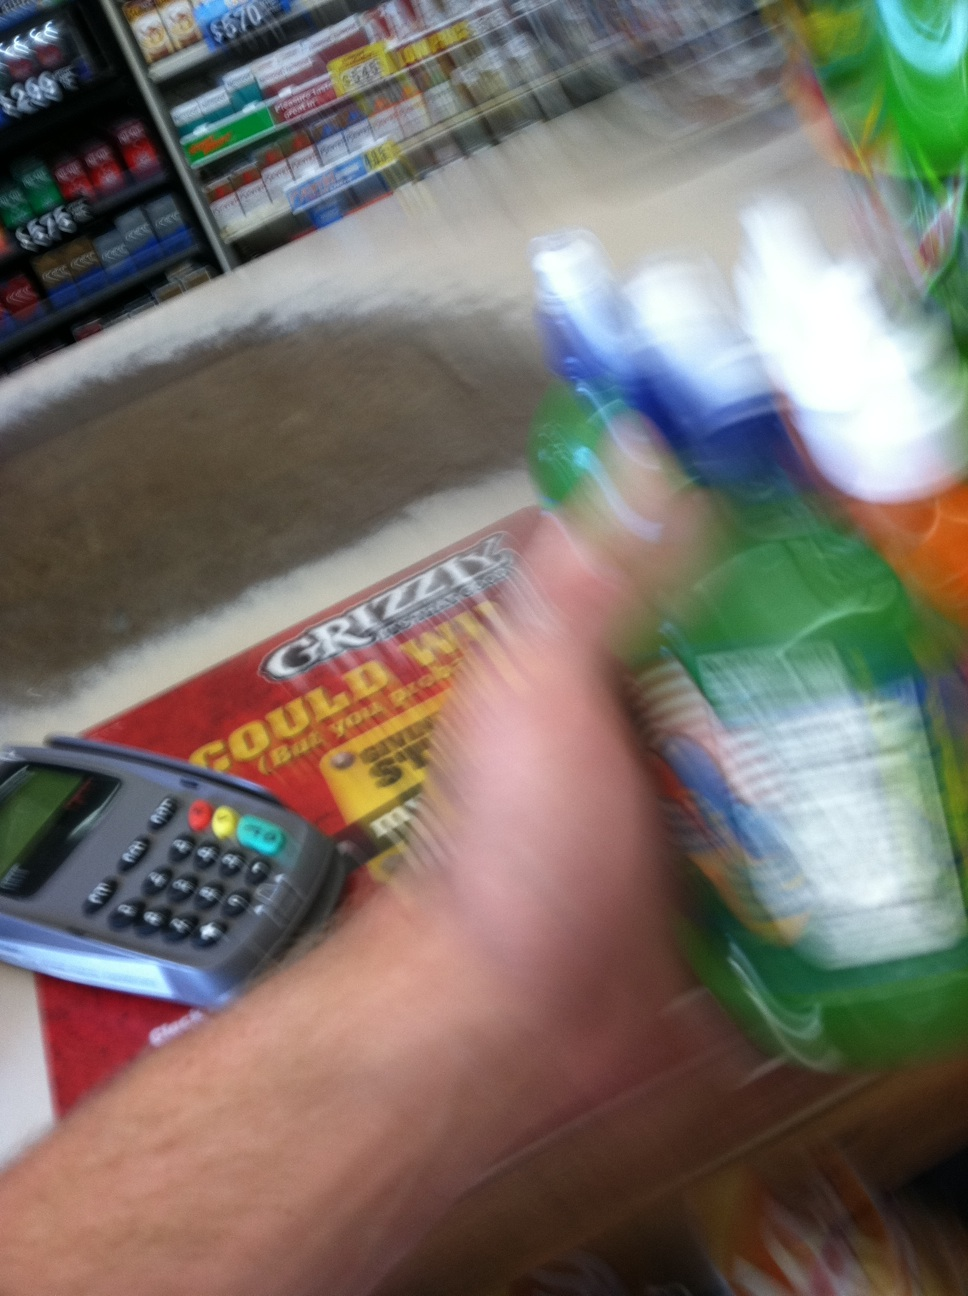Can you tell me more about the products being purchased in this image? It appears the products are various bottled beverages, possibly sodas or flavored waters, held by a customer at a store checkout. The exact brands are not clear due to the motion blur. Is there anything unusual about how the image was taken? Yes, the image seems to be taken in a hurry or in motion, resulting in a significant blur. This suggests a spontaneous, possibly unintentional photo capture during the shopping process. 